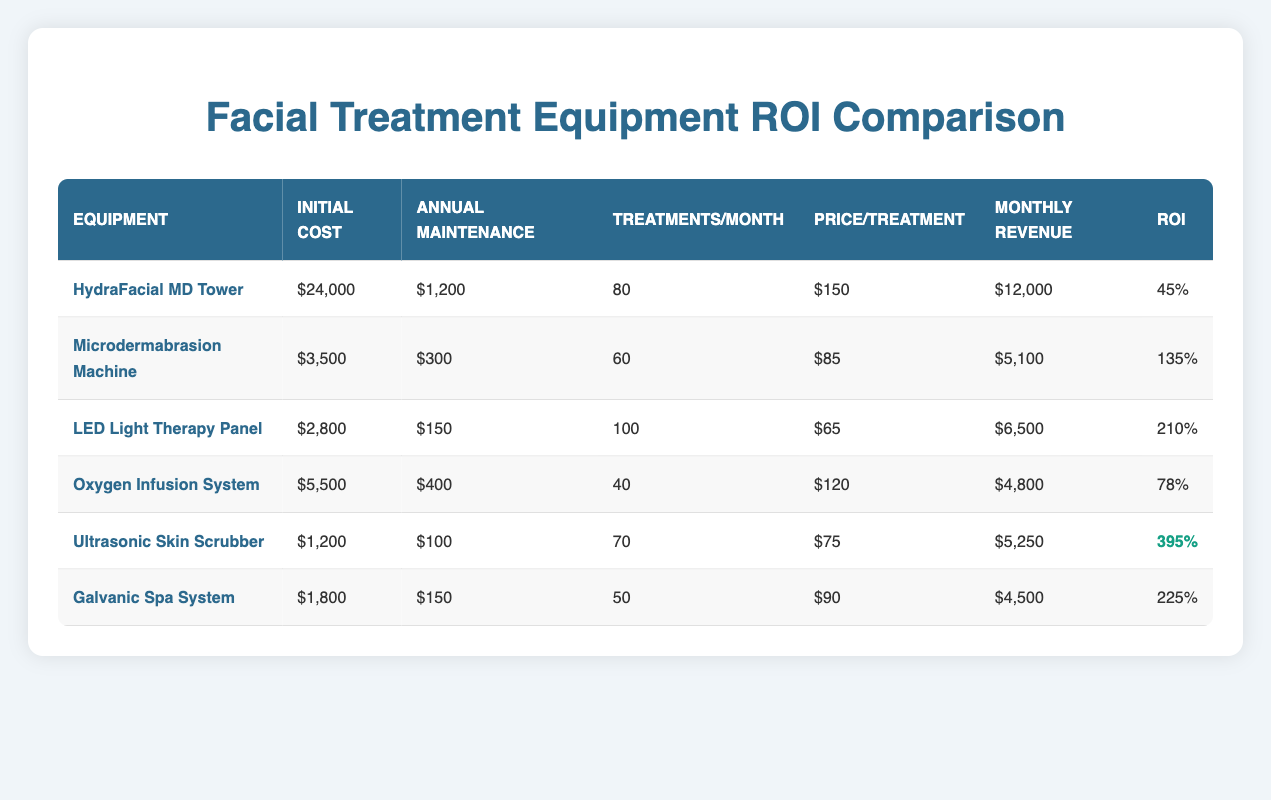What is the initial cost of the LED Light Therapy Panel? The table lists the initial cost of each equipment item. For the LED Light Therapy Panel, it is specified as 2,800.
Answer: 2,800 Which equipment has the highest ROI percentage? Looking at the ROI percentages for each equipment, the Ultrasonic Skin Scrubber is highlighted with the highest value of 395.
Answer: 395 How much monthly revenue does the Microdermabrasion Machine generate? The table directly states that the monthly revenue for the Microdermabrasion Machine is 5,100.
Answer: 5,100 What is the difference in initial cost between the HydraFacial MD Tower and the Galvanic Spa System? The initial cost of the HydraFacial MD Tower is 24,000 and the Galvanic Spa System is 1,800. The difference is calculated as 24,000 - 1,800 = 22,200.
Answer: 22,200 Is the annual maintenance cost of the Oxygen Infusion System higher than that of the Ultralonic Skin Scrubber? The Oxygen Infusion System's annual maintenance cost is 400 and the Ultrasonic Skin Scrubber's is 100. Since 400 is greater than 100, the statement is true.
Answer: Yes What is the average ROI of all the equipment listed? To find the average ROI, sum the ROI percentages: 45 + 135 + 210 + 78 + 395 + 225 = 1,088, then divide by the number of equipment (6): 1,088/6 = 181.33, rounded to two decimal places.
Answer: 181.33 How many treatments per month does the equipment with the lowest initial cost provide? The equipment with the lowest initial cost is the Ultrasonic Skin Scrubber, which offers 70 treatments per month as stated in the table.
Answer: 70 Does the LED Light Therapy Panel generate more monthly revenue than the Oxygen Infusion System? The monthly revenue for the LED Light Therapy Panel is 6,500, while for the Oxygen Infusion System it is 4,800. Since 6,500 is greater than 4,800, the statement is true.
Answer: Yes What are the total monthly revenues for the two highest ROI equipment options? The two highest ROIs are for the Ultrasonic Skin Scrubber (5,250) and the Galvanic Spa System (4,500). Their total monthly revenues are calculated as 5,250 + 4,500 = 9,750.
Answer: 9,750 